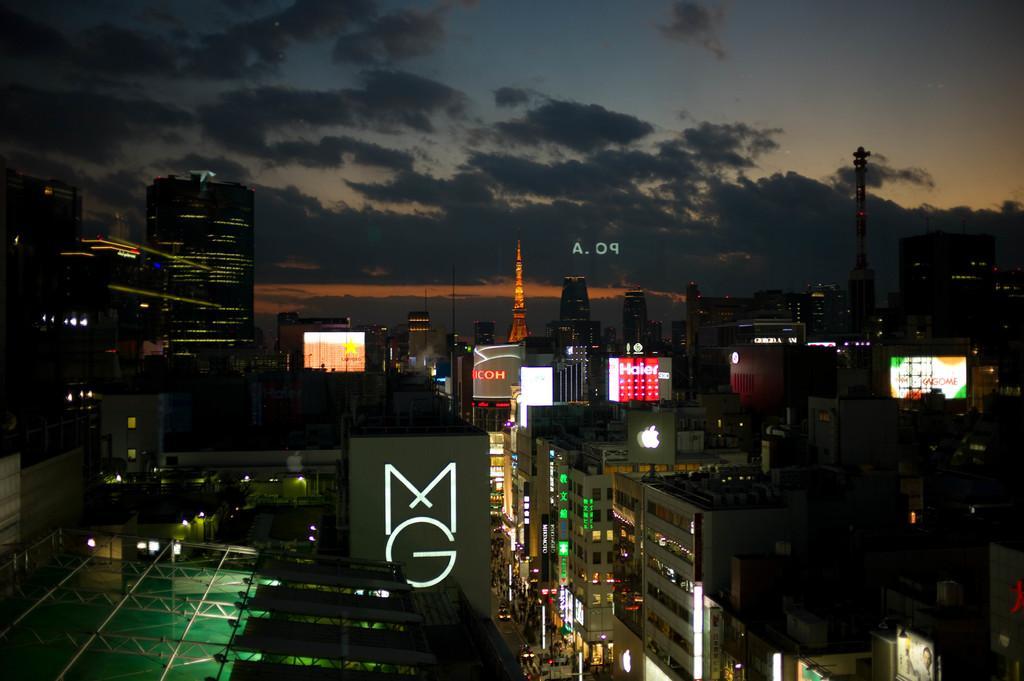Could you give a brief overview of what you see in this image? This picture is clicked outside the city. In the foreground we can see the buildings, towers and skyscrapers. In the background there is a sky which is full of clouds and we can can see the boards. 